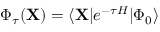Convert formula to latex. <formula><loc_0><loc_0><loc_500><loc_500>\begin{array} { r } { \Phi _ { \tau } ( X ) = \langle X | e ^ { - \tau H } | \Phi _ { 0 } \rangle } \end{array}</formula> 